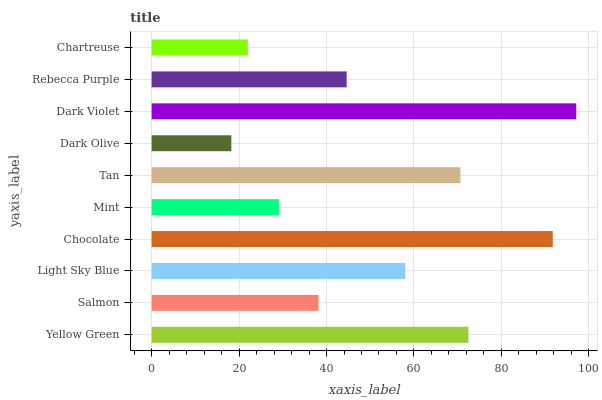Is Dark Olive the minimum?
Answer yes or no. Yes. Is Dark Violet the maximum?
Answer yes or no. Yes. Is Salmon the minimum?
Answer yes or no. No. Is Salmon the maximum?
Answer yes or no. No. Is Yellow Green greater than Salmon?
Answer yes or no. Yes. Is Salmon less than Yellow Green?
Answer yes or no. Yes. Is Salmon greater than Yellow Green?
Answer yes or no. No. Is Yellow Green less than Salmon?
Answer yes or no. No. Is Light Sky Blue the high median?
Answer yes or no. Yes. Is Rebecca Purple the low median?
Answer yes or no. Yes. Is Dark Violet the high median?
Answer yes or no. No. Is Dark Olive the low median?
Answer yes or no. No. 